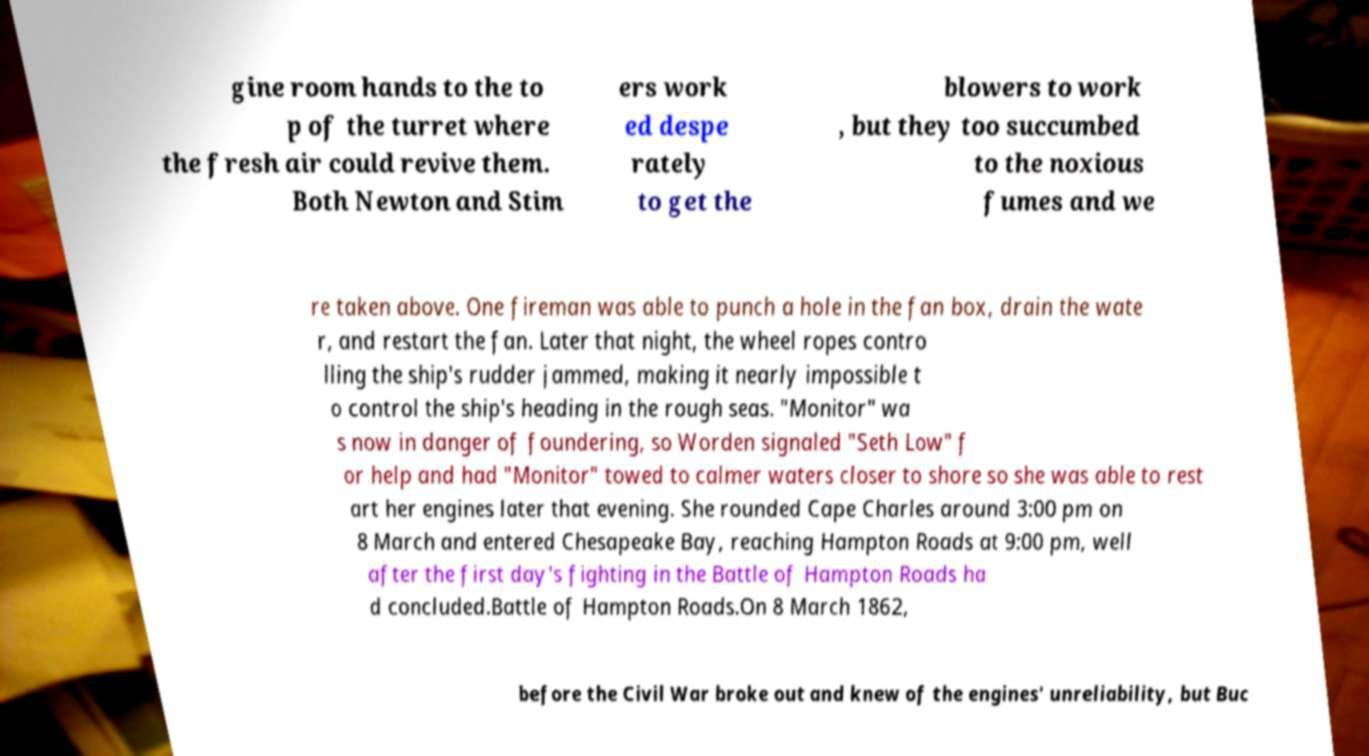There's text embedded in this image that I need extracted. Can you transcribe it verbatim? gine room hands to the to p of the turret where the fresh air could revive them. Both Newton and Stim ers work ed despe rately to get the blowers to work , but they too succumbed to the noxious fumes and we re taken above. One fireman was able to punch a hole in the fan box, drain the wate r, and restart the fan. Later that night, the wheel ropes contro lling the ship's rudder jammed, making it nearly impossible t o control the ship's heading in the rough seas. "Monitor" wa s now in danger of foundering, so Worden signaled "Seth Low" f or help and had "Monitor" towed to calmer waters closer to shore so she was able to rest art her engines later that evening. She rounded Cape Charles around 3:00 pm on 8 March and entered Chesapeake Bay, reaching Hampton Roads at 9:00 pm, well after the first day's fighting in the Battle of Hampton Roads ha d concluded.Battle of Hampton Roads.On 8 March 1862, before the Civil War broke out and knew of the engines' unreliability, but Buc 